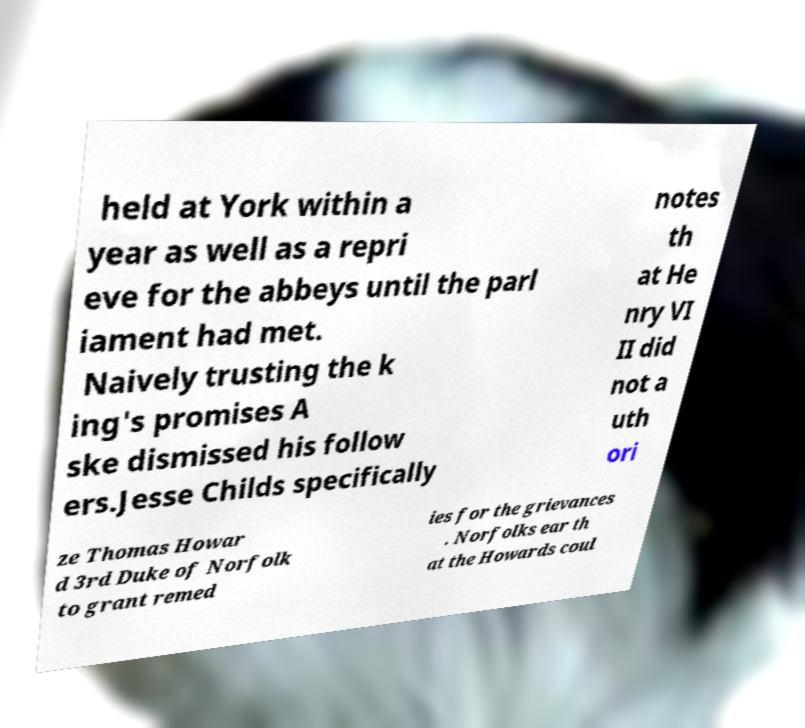Can you read and provide the text displayed in the image?This photo seems to have some interesting text. Can you extract and type it out for me? held at York within a year as well as a repri eve for the abbeys until the parl iament had met. Naively trusting the k ing's promises A ske dismissed his follow ers.Jesse Childs specifically notes th at He nry VI II did not a uth ori ze Thomas Howar d 3rd Duke of Norfolk to grant remed ies for the grievances . Norfolks ear th at the Howards coul 